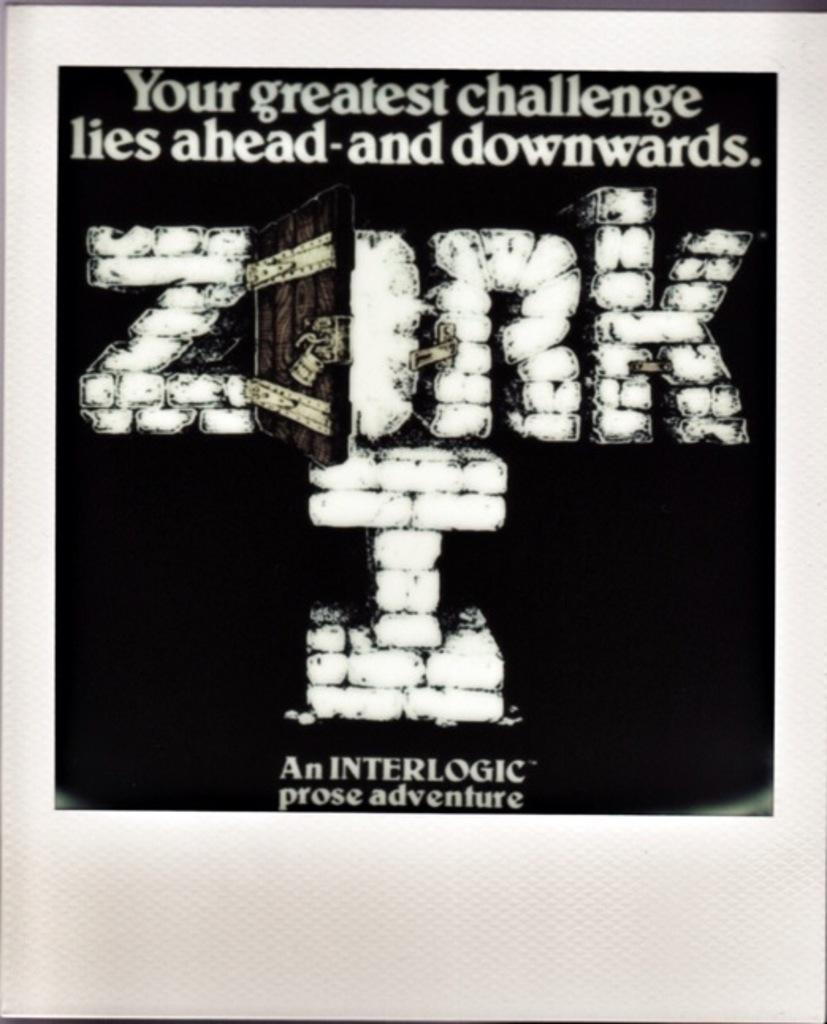What is present on the poster in the image? There is a poster in the image. What can be found on the poster besides the image itself? There is text on the poster. What type of cherry is depicted on the poster? There is no cherry present on the poster; it only contains text and an image. How does the yam contribute to the message on the poster? There is no yam present on the poster; it only contains text and an image. 